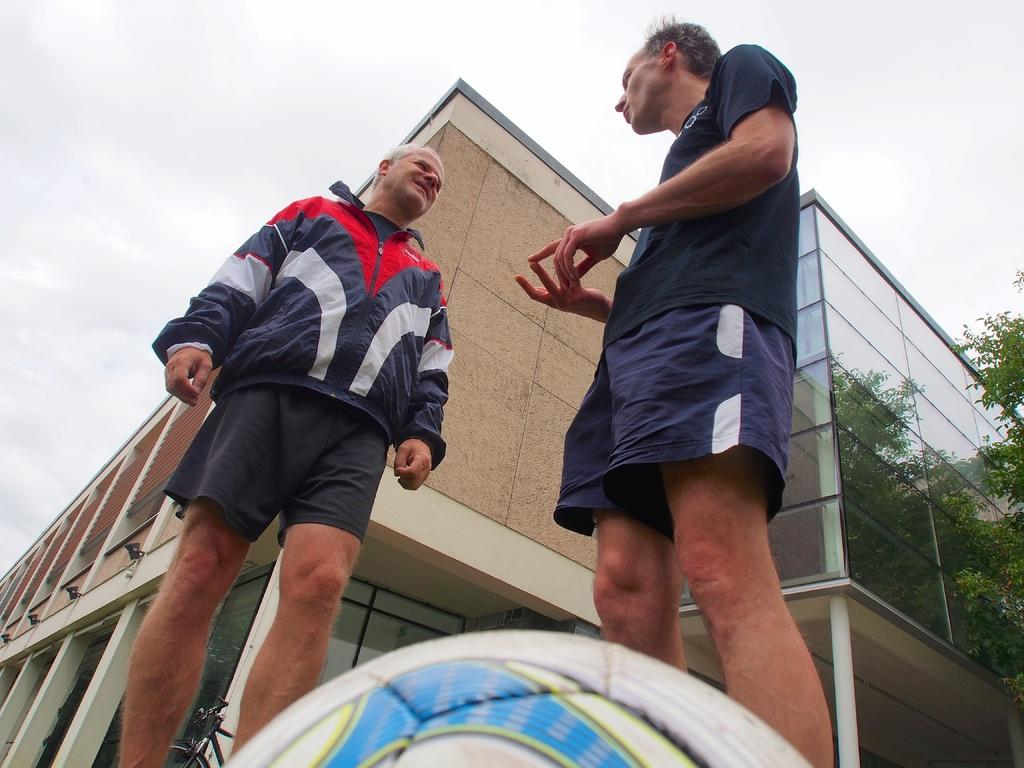How many people are in the image? There are two persons standing in the image. What are the people doing in the image? The persons are facing each other. What can be seen in the background of the image? There are buildings with glass and trees in the background of the image. Is there any transportation visible in the background? Yes, there is a bicycle in the background of the image. What type of pets are playing in the camp shown in the image? There is no camp or pets present in the image. What sound can be heard coming from the buildings in the image? The image does not include any sounds or audio information, so it is not possible to determine what sound might be heard. 